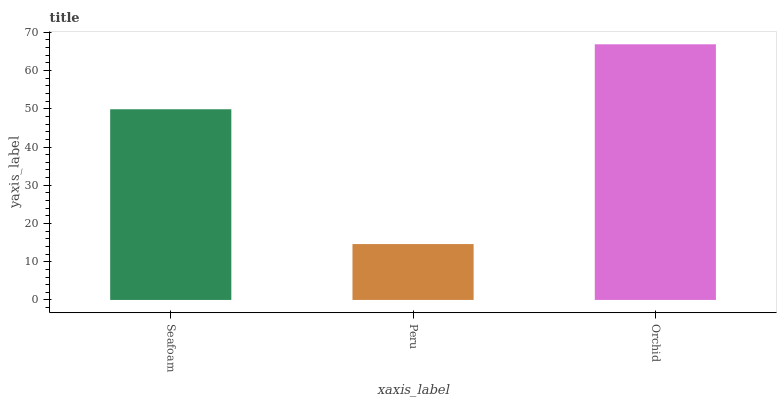Is Peru the minimum?
Answer yes or no. Yes. Is Orchid the maximum?
Answer yes or no. Yes. Is Orchid the minimum?
Answer yes or no. No. Is Peru the maximum?
Answer yes or no. No. Is Orchid greater than Peru?
Answer yes or no. Yes. Is Peru less than Orchid?
Answer yes or no. Yes. Is Peru greater than Orchid?
Answer yes or no. No. Is Orchid less than Peru?
Answer yes or no. No. Is Seafoam the high median?
Answer yes or no. Yes. Is Seafoam the low median?
Answer yes or no. Yes. Is Peru the high median?
Answer yes or no. No. Is Orchid the low median?
Answer yes or no. No. 